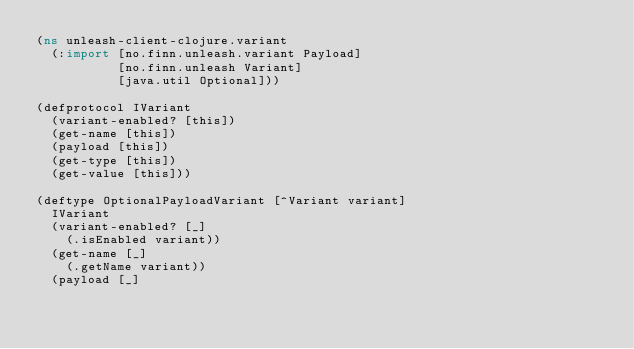<code> <loc_0><loc_0><loc_500><loc_500><_Clojure_>(ns unleash-client-clojure.variant
  (:import [no.finn.unleash.variant Payload]
           [no.finn.unleash Variant]
           [java.util Optional]))

(defprotocol IVariant
  (variant-enabled? [this])
  (get-name [this])
  (payload [this])
  (get-type [this])
  (get-value [this]))

(deftype OptionalPayloadVariant [^Variant variant]
  IVariant
  (variant-enabled? [_]
    (.isEnabled variant))
  (get-name [_]
    (.getName variant))
  (payload [_]</code> 